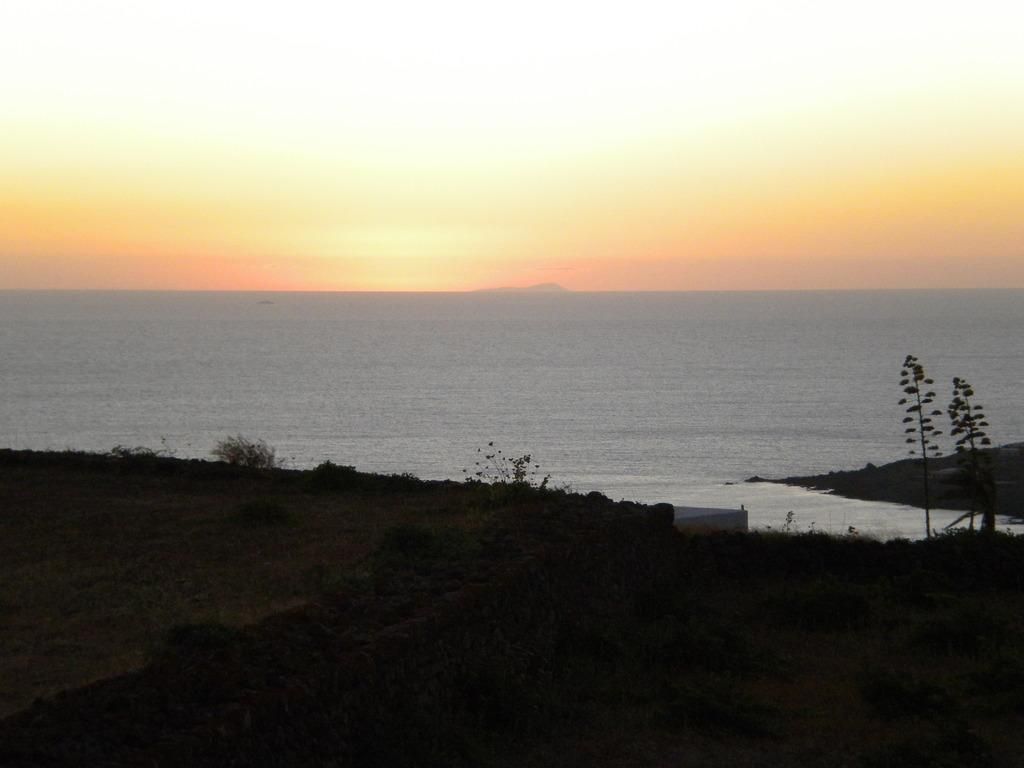What type of vegetation is present in the image? There is grass and a plant in the image. What can be seen in the background of the image? The sky is visible in the image. Is there any water visible in the image? Yes, there is water visible in the image. What type of engine can be seen in the image? There is no engine present in the image. Is there a pig visible in the image? There is no pig present in the image. 